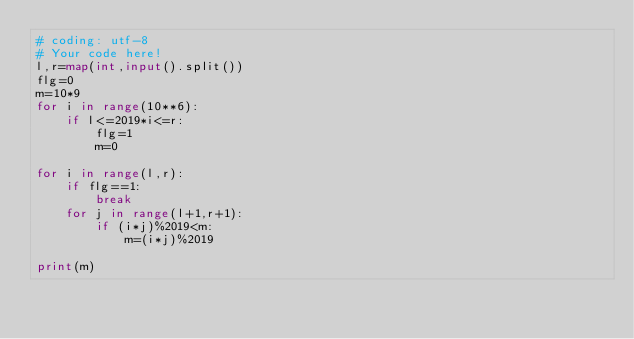<code> <loc_0><loc_0><loc_500><loc_500><_Python_># coding: utf-8
# Your code here!
l,r=map(int,input().split())
flg=0
m=10*9
for i in range(10**6):
    if l<=2019*i<=r:
        flg=1
        m=0

for i in range(l,r): 
    if flg==1:
        break
    for j in range(l+1,r+1):
        if (i*j)%2019<m:
            m=(i*j)%2019

print(m)
</code> 